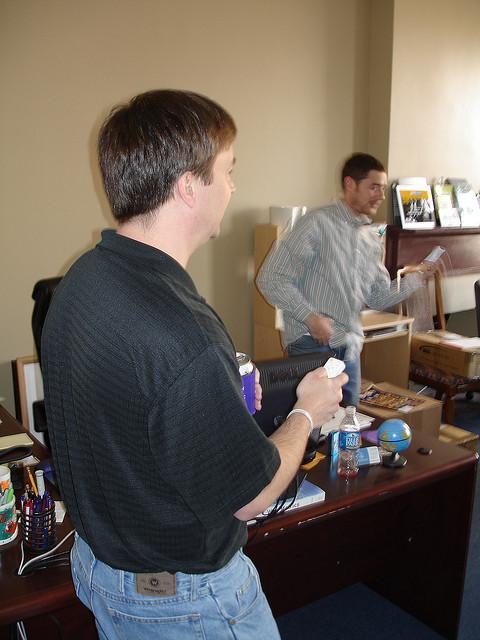How many people are playing?
Give a very brief answer. 2. How many people are in the picture?
Give a very brief answer. 2. How many chairs are there?
Give a very brief answer. 2. 